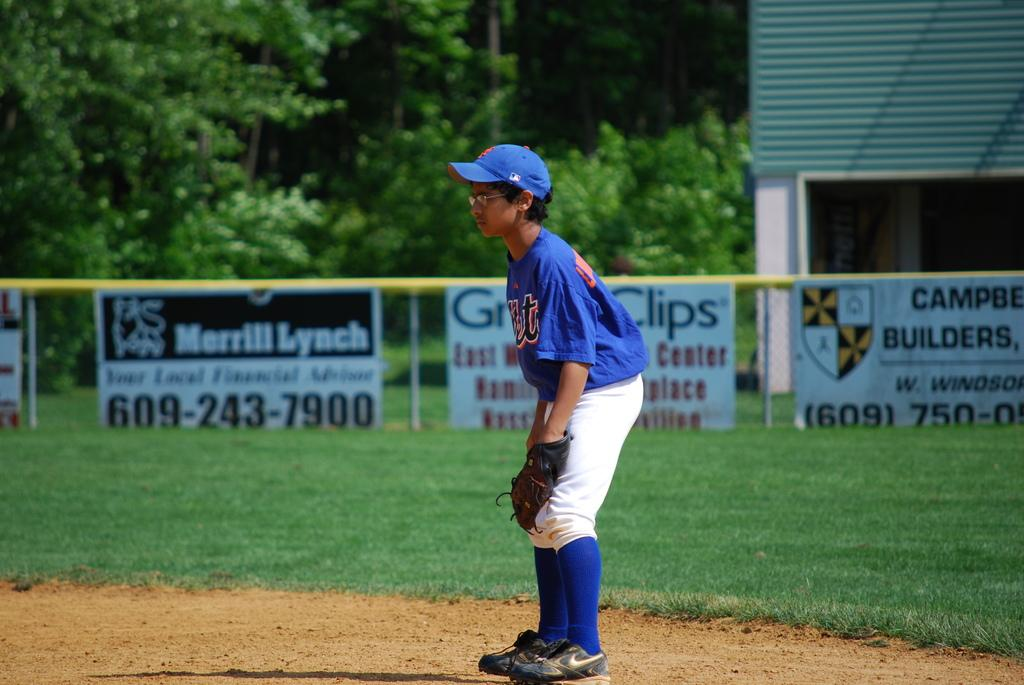<image>
Describe the image concisely. A boy in a baseball uniform is on the field somewhere in the 609 area code. 